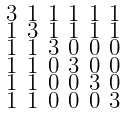Convert formula to latex. <formula><loc_0><loc_0><loc_500><loc_500>\begin{smallmatrix} 3 & 1 & 1 & 1 & 1 & 1 \\ 1 & 3 & 1 & 1 & 1 & 1 \\ 1 & 1 & 3 & 0 & 0 & 0 \\ 1 & 1 & 0 & 3 & 0 & 0 \\ 1 & 1 & 0 & 0 & 3 & 0 \\ 1 & 1 & 0 & 0 & 0 & 3 \end{smallmatrix}</formula> 